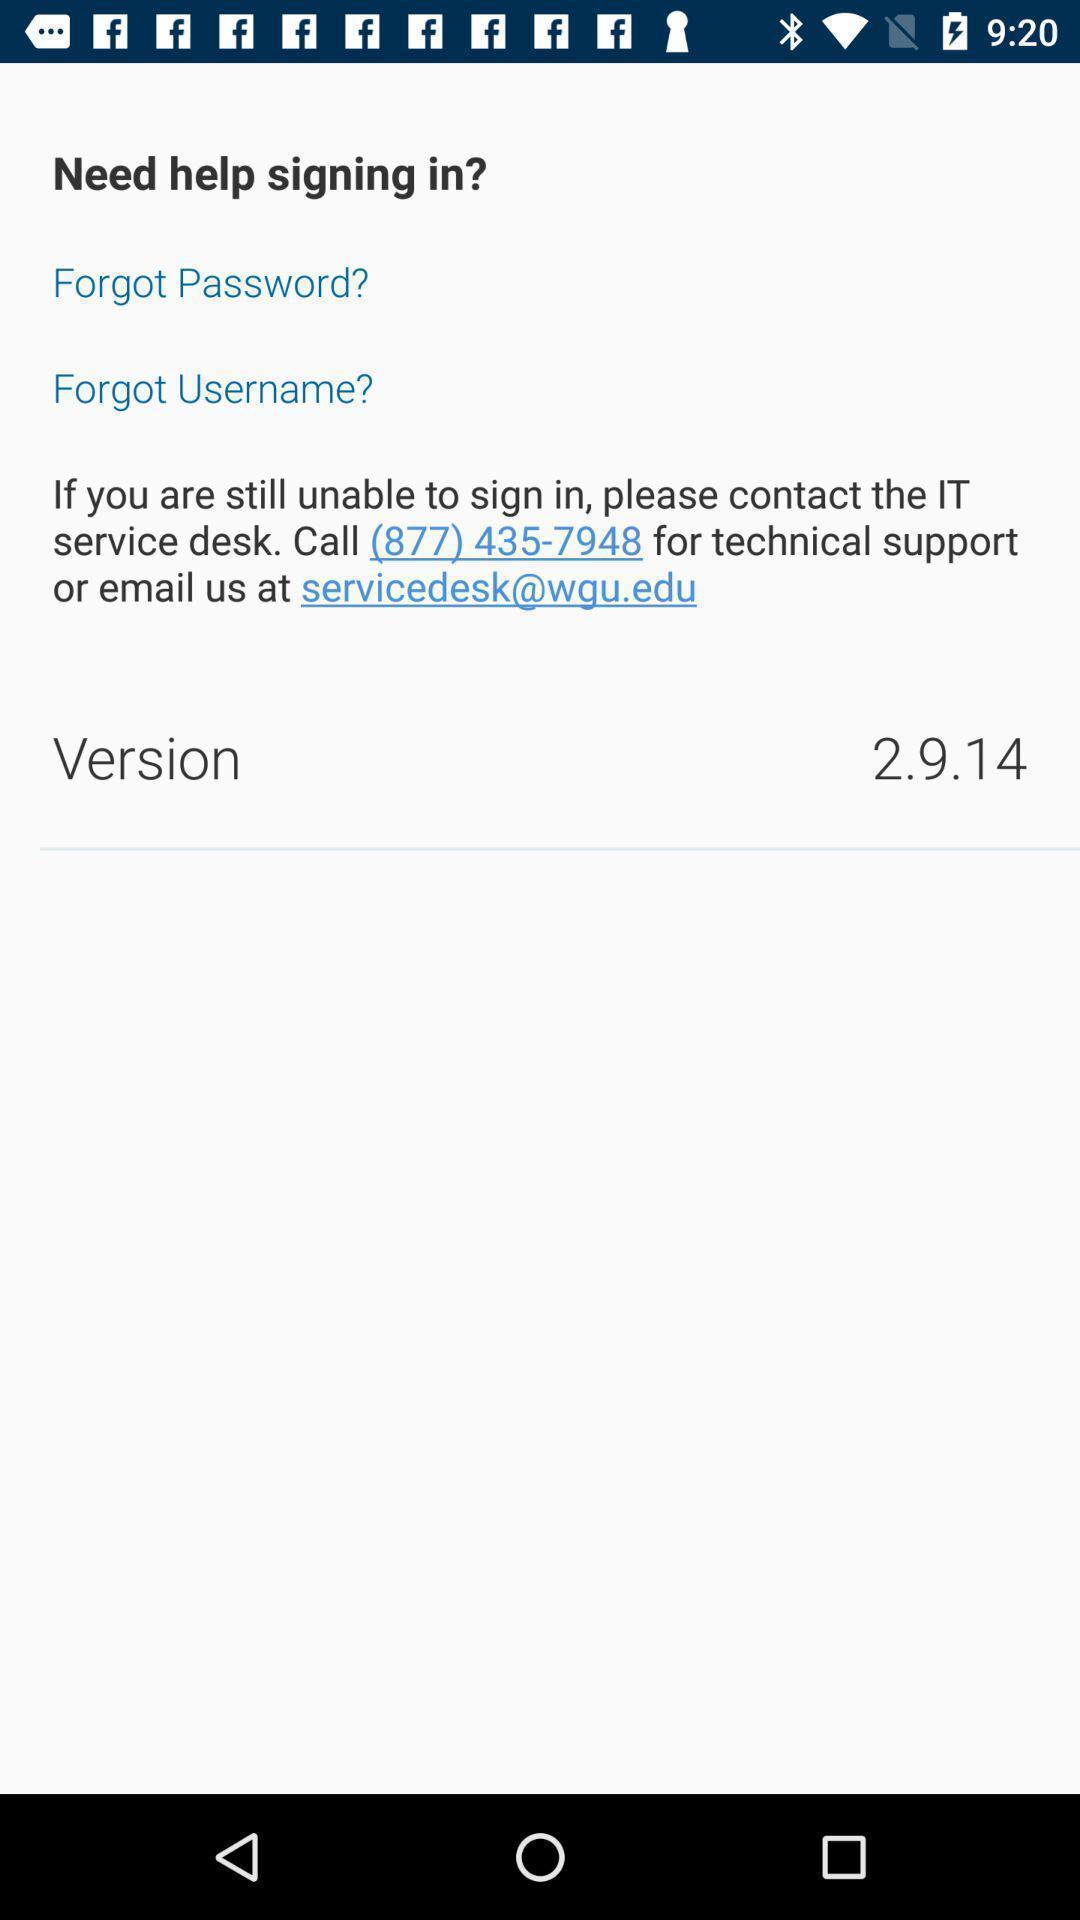Explain the elements present in this screenshot. Sign in page. 